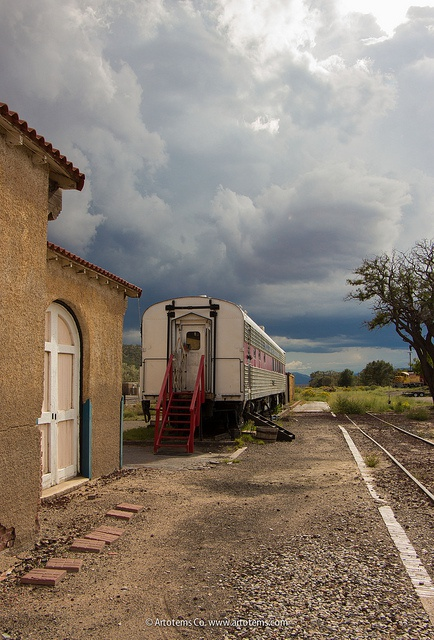Describe the objects in this image and their specific colors. I can see a train in darkgray, gray, and black tones in this image. 